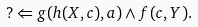<formula> <loc_0><loc_0><loc_500><loc_500>? \Leftarrow g ( h ( X , c ) , a ) \wedge f ( c , Y ) .</formula> 